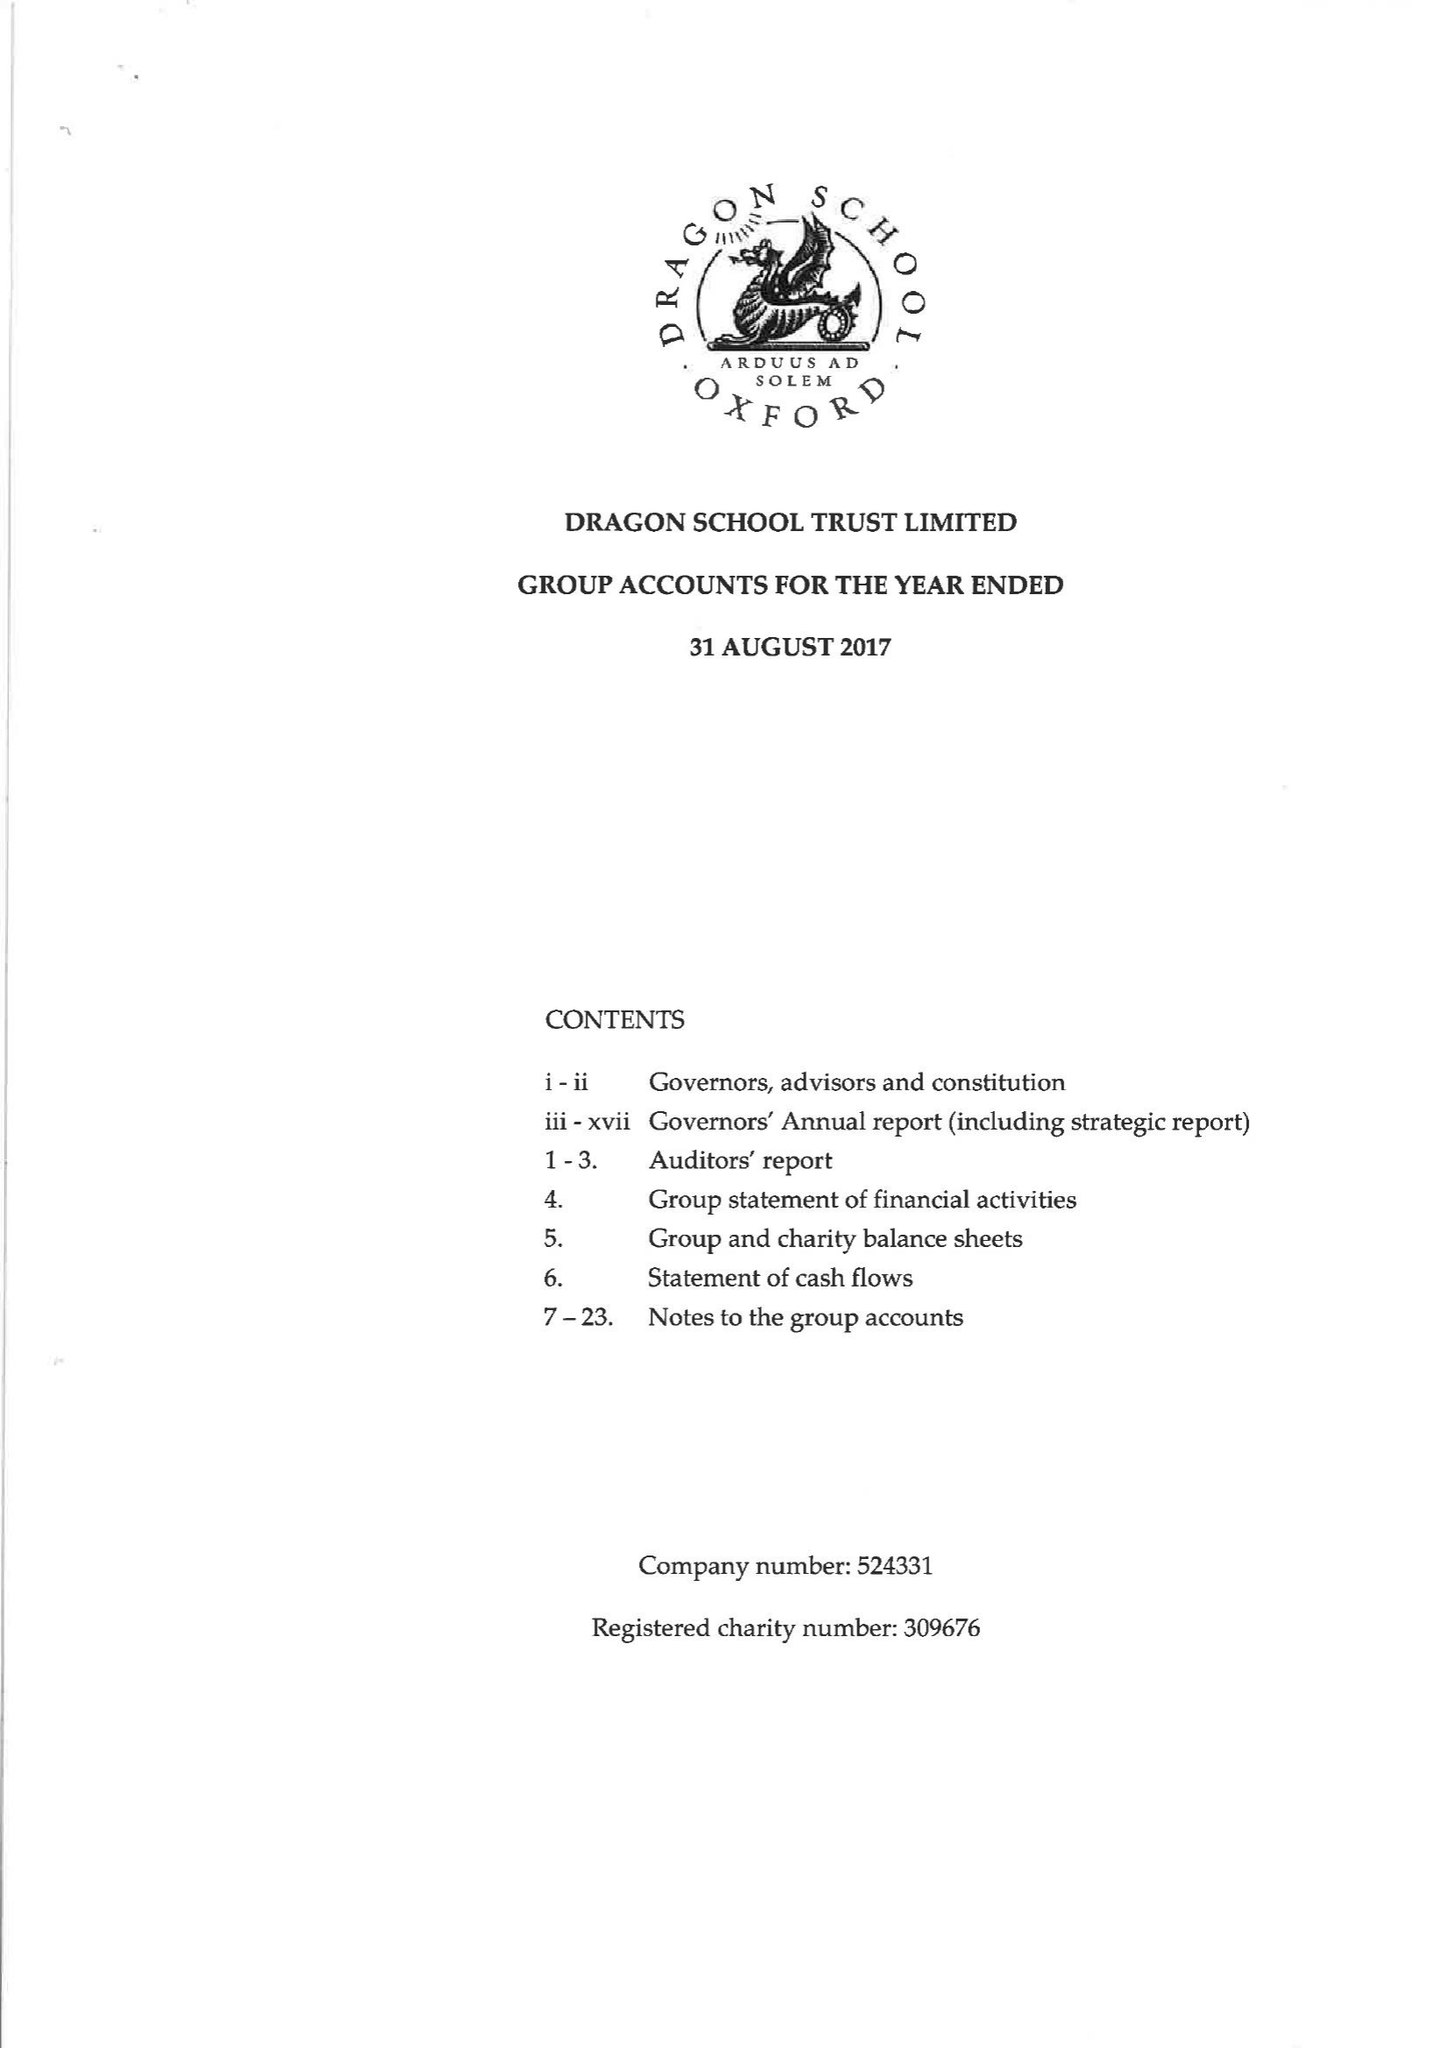What is the value for the income_annually_in_british_pounds?
Answer the question using a single word or phrase. 18209000.00 